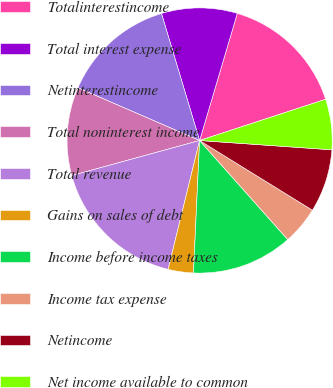<chart> <loc_0><loc_0><loc_500><loc_500><pie_chart><fcel>Totalinterestincome<fcel>Total interest expense<fcel>Netinterestincome<fcel>Total noninterest income<fcel>Total revenue<fcel>Gains on sales of debt<fcel>Income before income taxes<fcel>Income tax expense<fcel>Netincome<fcel>Net income available to common<nl><fcel>15.38%<fcel>9.23%<fcel>13.85%<fcel>10.77%<fcel>16.92%<fcel>3.08%<fcel>12.31%<fcel>4.62%<fcel>7.69%<fcel>6.15%<nl></chart> 